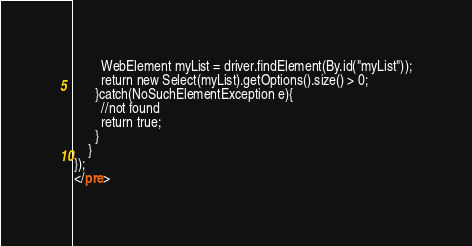Convert code to text. <code><loc_0><loc_0><loc_500><loc_500><_HTML_>        WebElement myList = driver.findElement(By.id("myList"));
        return new Select(myList).getOptions().size() > 0;
      }catch(NoSuchElementException e){
        //not found
        return true;
      }
    }
});
</pre>
</code> 